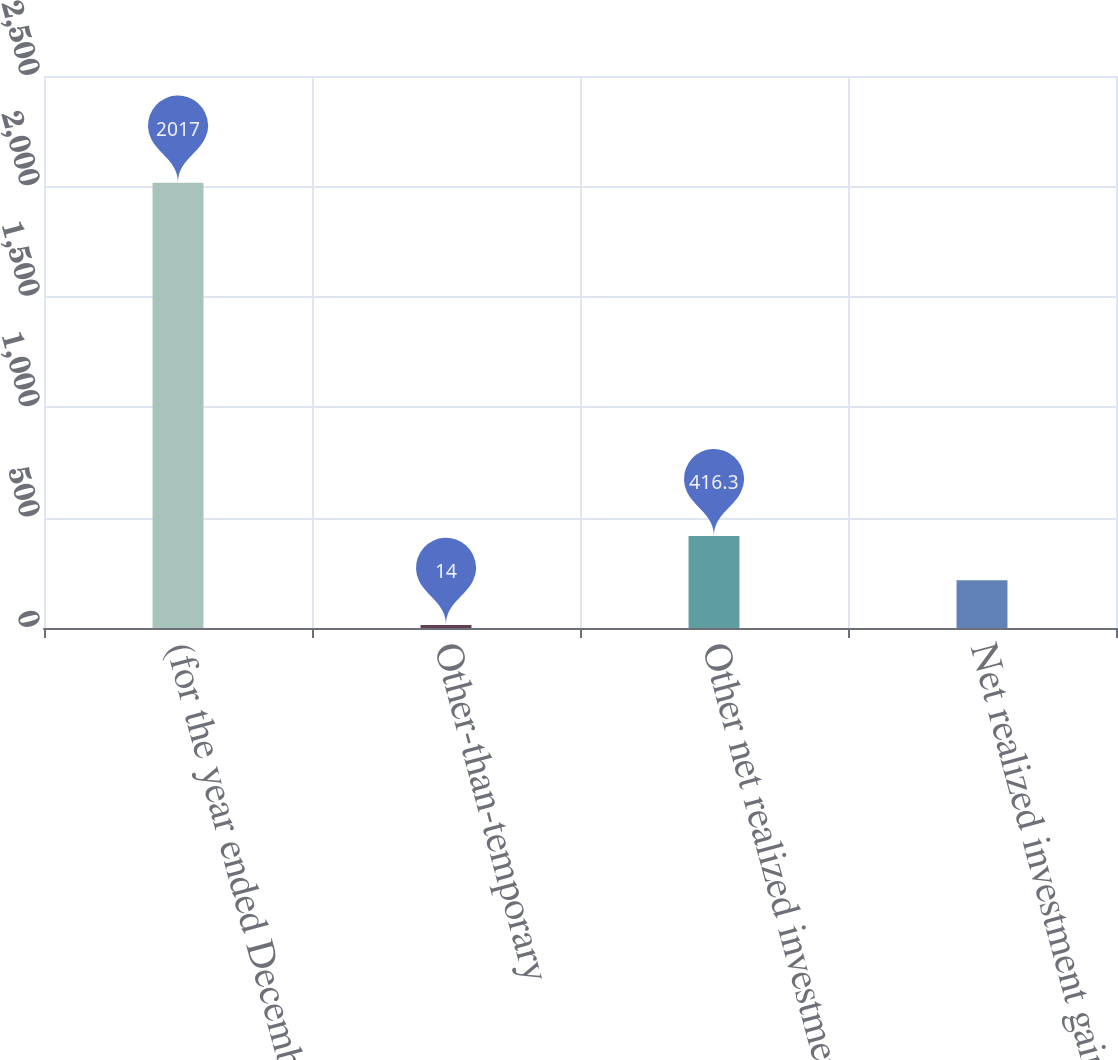Convert chart to OTSL. <chart><loc_0><loc_0><loc_500><loc_500><bar_chart><fcel>(for the year ended December<fcel>Other-than-temporary<fcel>Other net realized investment<fcel>Net realized investment gains<nl><fcel>2017<fcel>14<fcel>416.3<fcel>216<nl></chart> 